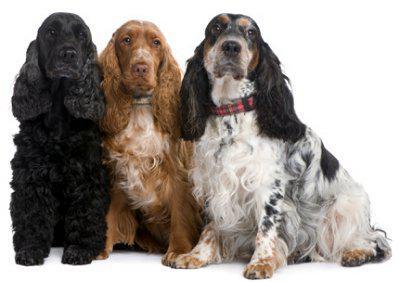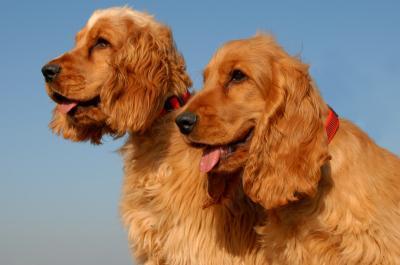The first image is the image on the left, the second image is the image on the right. Considering the images on both sides, is "An image includes at least three dogs of different colors." valid? Answer yes or no. Yes. The first image is the image on the left, the second image is the image on the right. Evaluate the accuracy of this statement regarding the images: "The right image contains exactly two dogs.". Is it true? Answer yes or no. Yes. 